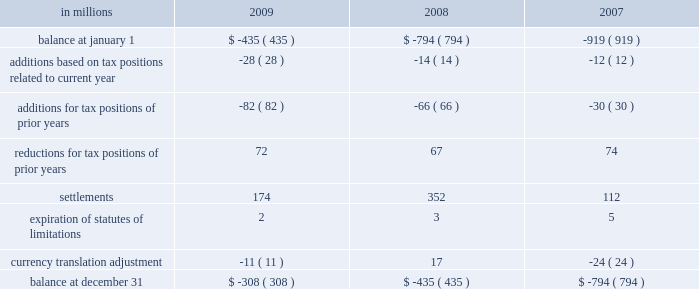Deferred tax assets and liabilities are recorded in the accompanying consolidated balance sheet under the captions deferred income tax assets , deferred charges and other assets , other accrued liabilities and deferred income taxes .
The decrease in 2009 in deferred tax assets principally relates to the tax impact of changes in recorded qualified pension liabilities , minimum tax credit utilization and an increase in the valuation allowance .
The decrease in deferred income tax liabilities principally relates to less tax depreciation taken on the company 2019s assets purchased in 2009 .
The valuation allowance for deferred tax assets as of december 31 , 2008 was $ 72 million .
The net change in the total valuation allowance for the year ended december 31 , 2009 , was an increase of $ 274 million .
The increase of $ 274 million consists primarily of : ( 1 ) $ 211 million related to the company 2019s french operations , including a valuation allowance of $ 55 million against net deferred tax assets from current year operations and $ 156 million recorded in the second quarter of 2009 for the establishment of a valuation allowance against previously recorded deferred tax assets , ( 2 ) $ 10 million for net deferred tax assets arising from the company 2019s united king- dom current year operations , and ( 3 ) $ 47 million related to a reduction of previously recorded u.s .
State deferred tax assets , including $ 15 million recorded in the fourth quarter of 2009 for louisiana recycling credits .
The effect on the company 2019s effec- tive tax rate of the aforementioned $ 211 million and $ 10 million is included in the line item 201ctax rate and permanent differences on non-u.s .
Earnings . 201d international paper adopted the provisions of new guidance under asc 740 , 201cincome taxes , 201d on jan- uary 1 , 2007 related to uncertain tax positions .
As a result of the implementation of this new guidance , the company recorded a charge to the beginning balance of retained earnings of $ 94 million , which was accounted for as a reduction to the january 1 , 2007 balance of retained earnings .
A reconciliation of the beginning and ending amount of unrecognized tax benefits for the year ending december 31 , 2009 and 2008 is as follows : in millions 2009 2008 2007 .
Included in the balance at december 31 , 2009 and 2008 are $ 56 million and $ 9 million , respectively , for tax positions for which the ultimate benefits are highly certain , but for which there is uncertainty about the timing of such benefits .
However , except for the possible effect of any penalties , any dis- allowance that would change the timing of these benefits would not affect the annual effective tax rate , but would accelerate the payment of cash to the taxing authority to an earlier period .
The company accrues interest on unrecognized tax benefits as a component of interest expense .
Penal- ties , if incurred , are recognized as a component of income tax expense .
The company had approx- imately $ 95 million and $ 74 million accrued for the payment of estimated interest and penalties asso- ciated with unrecognized tax benefits at december 31 , 2009 and 2008 , respectively .
The major jurisdictions where the company files income tax returns are the united states , brazil , france , poland and russia .
Generally , tax years 2002 through 2009 remain open and subject to examina- tion by the relevant tax authorities .
The company is typically engaged in various tax examinations at any given time , both in the united states and overseas .
Currently , the company is engaged in discussions with the u.s .
Internal revenue service regarding the examination of tax years 2006 and 2007 .
As a result of these discussions , other pending tax audit settle- ments , and the expiration of statutes of limitation , the company currently estimates that the amount of unrecognized tax benefits could be reduced by up to $ 125 million during the next twelve months .
During 2009 , unrecognized tax benefits decreased by $ 127 million .
While the company believes that it is adequately accrued for possible audit adjustments , the final resolution of these examinations cannot be determined at this time and could result in final settlements that differ from current estimates .
The company 2019s 2009 income tax provision of $ 469 million included $ 279 million related to special items and other charges , consisting of a $ 534 million tax benefit related to restructuring and other charges , a $ 650 million tax expense for the alternative fuel mixture credit , and $ 163 million of tax-related adjustments including a $ 156 million tax expense to establish a valuation allowance for net operating loss carryforwards in france , a $ 26 million tax benefit for the effective settlement of federal tax audits , a $ 15 million tax expense to establish a valuation allow- ance for louisiana recycling credits , and $ 18 million of other income tax adjustments .
Excluding the impact of special items , the tax provision was .
What was the change in unrecognized tax benefits between 2008 and 2009? 
Computations: (-308 - -435)
Answer: 127.0. Deferred tax assets and liabilities are recorded in the accompanying consolidated balance sheet under the captions deferred income tax assets , deferred charges and other assets , other accrued liabilities and deferred income taxes .
The decrease in 2009 in deferred tax assets principally relates to the tax impact of changes in recorded qualified pension liabilities , minimum tax credit utilization and an increase in the valuation allowance .
The decrease in deferred income tax liabilities principally relates to less tax depreciation taken on the company 2019s assets purchased in 2009 .
The valuation allowance for deferred tax assets as of december 31 , 2008 was $ 72 million .
The net change in the total valuation allowance for the year ended december 31 , 2009 , was an increase of $ 274 million .
The increase of $ 274 million consists primarily of : ( 1 ) $ 211 million related to the company 2019s french operations , including a valuation allowance of $ 55 million against net deferred tax assets from current year operations and $ 156 million recorded in the second quarter of 2009 for the establishment of a valuation allowance against previously recorded deferred tax assets , ( 2 ) $ 10 million for net deferred tax assets arising from the company 2019s united king- dom current year operations , and ( 3 ) $ 47 million related to a reduction of previously recorded u.s .
State deferred tax assets , including $ 15 million recorded in the fourth quarter of 2009 for louisiana recycling credits .
The effect on the company 2019s effec- tive tax rate of the aforementioned $ 211 million and $ 10 million is included in the line item 201ctax rate and permanent differences on non-u.s .
Earnings . 201d international paper adopted the provisions of new guidance under asc 740 , 201cincome taxes , 201d on jan- uary 1 , 2007 related to uncertain tax positions .
As a result of the implementation of this new guidance , the company recorded a charge to the beginning balance of retained earnings of $ 94 million , which was accounted for as a reduction to the january 1 , 2007 balance of retained earnings .
A reconciliation of the beginning and ending amount of unrecognized tax benefits for the year ending december 31 , 2009 and 2008 is as follows : in millions 2009 2008 2007 .
Included in the balance at december 31 , 2009 and 2008 are $ 56 million and $ 9 million , respectively , for tax positions for which the ultimate benefits are highly certain , but for which there is uncertainty about the timing of such benefits .
However , except for the possible effect of any penalties , any dis- allowance that would change the timing of these benefits would not affect the annual effective tax rate , but would accelerate the payment of cash to the taxing authority to an earlier period .
The company accrues interest on unrecognized tax benefits as a component of interest expense .
Penal- ties , if incurred , are recognized as a component of income tax expense .
The company had approx- imately $ 95 million and $ 74 million accrued for the payment of estimated interest and penalties asso- ciated with unrecognized tax benefits at december 31 , 2009 and 2008 , respectively .
The major jurisdictions where the company files income tax returns are the united states , brazil , france , poland and russia .
Generally , tax years 2002 through 2009 remain open and subject to examina- tion by the relevant tax authorities .
The company is typically engaged in various tax examinations at any given time , both in the united states and overseas .
Currently , the company is engaged in discussions with the u.s .
Internal revenue service regarding the examination of tax years 2006 and 2007 .
As a result of these discussions , other pending tax audit settle- ments , and the expiration of statutes of limitation , the company currently estimates that the amount of unrecognized tax benefits could be reduced by up to $ 125 million during the next twelve months .
During 2009 , unrecognized tax benefits decreased by $ 127 million .
While the company believes that it is adequately accrued for possible audit adjustments , the final resolution of these examinations cannot be determined at this time and could result in final settlements that differ from current estimates .
The company 2019s 2009 income tax provision of $ 469 million included $ 279 million related to special items and other charges , consisting of a $ 534 million tax benefit related to restructuring and other charges , a $ 650 million tax expense for the alternative fuel mixture credit , and $ 163 million of tax-related adjustments including a $ 156 million tax expense to establish a valuation allowance for net operating loss carryforwards in france , a $ 26 million tax benefit for the effective settlement of federal tax audits , a $ 15 million tax expense to establish a valuation allow- ance for louisiana recycling credits , and $ 18 million of other income tax adjustments .
Excluding the impact of special items , the tax provision was .
Based on the review of the unrecognized tax benefits what was the average settlement amount from 2007 to 2009 in millions? 
Computations: ((((174 + 352) + 112) + 3) / 2)
Answer: 320.5. 